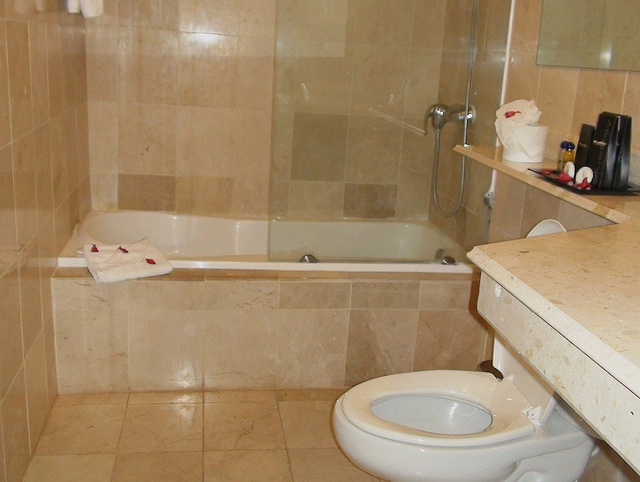Describe the objects in this image and their specific colors. I can see toilet in olive, darkgray, tan, and lightgray tones, bottle in olive, gray, and black tones, and bottle in olive, black, and maroon tones in this image. 